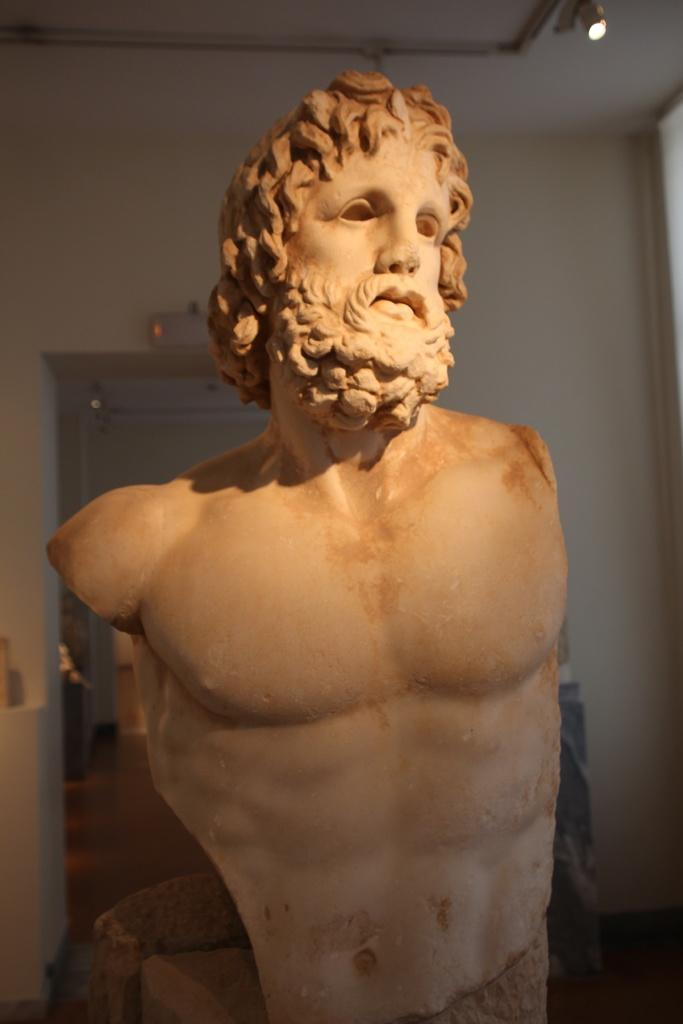What is the main subject of the image? The main subject of the image is a stone carving of a man. Can you describe the lighting in the image? There is light visible on the ceiling in the image. What type of zinc is being used to show respect in the image? There is no zinc or indication of respect present in the image; it features a stone carving of a man and light on the ceiling. What type of plate is being used to serve the food in the image? There is no plate or food present in the image; it only features a stone carving of a man and light on the ceiling. 